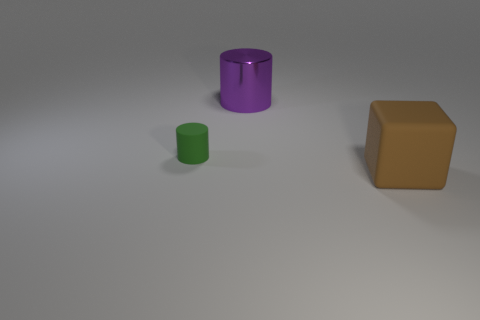How would the scene look like under bright sunlight? Under the bright sunlight, the scene would take on a more vivid appearance. The shadows cast by the objects would become sharply defined, with the contrasting areas of light and shadow accentuating the objects' shapes. The colors of the cylinders and the cube might appear more intense due to the increased illumination. 